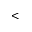Convert formula to latex. <formula><loc_0><loc_0><loc_500><loc_500><</formula> 